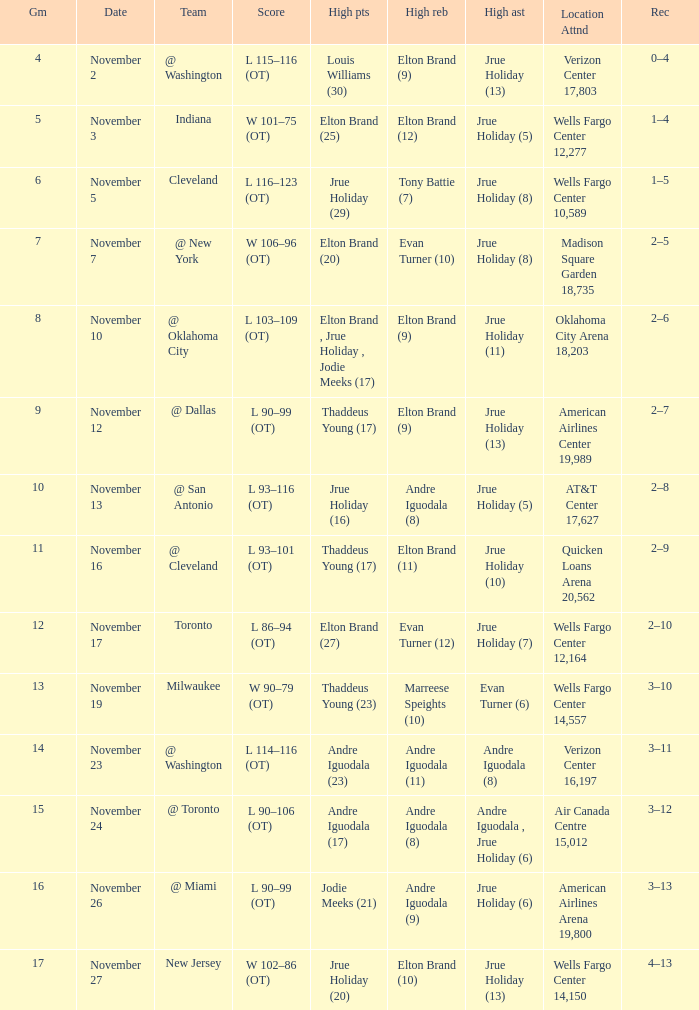What is the game number for the game with a score of l 90–106 (ot)? 15.0. Parse the table in full. {'header': ['Gm', 'Date', 'Team', 'Score', 'High pts', 'High reb', 'High ast', 'Location Attnd', 'Rec'], 'rows': [['4', 'November 2', '@ Washington', 'L 115–116 (OT)', 'Louis Williams (30)', 'Elton Brand (9)', 'Jrue Holiday (13)', 'Verizon Center 17,803', '0–4'], ['5', 'November 3', 'Indiana', 'W 101–75 (OT)', 'Elton Brand (25)', 'Elton Brand (12)', 'Jrue Holiday (5)', 'Wells Fargo Center 12,277', '1–4'], ['6', 'November 5', 'Cleveland', 'L 116–123 (OT)', 'Jrue Holiday (29)', 'Tony Battie (7)', 'Jrue Holiday (8)', 'Wells Fargo Center 10,589', '1–5'], ['7', 'November 7', '@ New York', 'W 106–96 (OT)', 'Elton Brand (20)', 'Evan Turner (10)', 'Jrue Holiday (8)', 'Madison Square Garden 18,735', '2–5'], ['8', 'November 10', '@ Oklahoma City', 'L 103–109 (OT)', 'Elton Brand , Jrue Holiday , Jodie Meeks (17)', 'Elton Brand (9)', 'Jrue Holiday (11)', 'Oklahoma City Arena 18,203', '2–6'], ['9', 'November 12', '@ Dallas', 'L 90–99 (OT)', 'Thaddeus Young (17)', 'Elton Brand (9)', 'Jrue Holiday (13)', 'American Airlines Center 19,989', '2–7'], ['10', 'November 13', '@ San Antonio', 'L 93–116 (OT)', 'Jrue Holiday (16)', 'Andre Iguodala (8)', 'Jrue Holiday (5)', 'AT&T Center 17,627', '2–8'], ['11', 'November 16', '@ Cleveland', 'L 93–101 (OT)', 'Thaddeus Young (17)', 'Elton Brand (11)', 'Jrue Holiday (10)', 'Quicken Loans Arena 20,562', '2–9'], ['12', 'November 17', 'Toronto', 'L 86–94 (OT)', 'Elton Brand (27)', 'Evan Turner (12)', 'Jrue Holiday (7)', 'Wells Fargo Center 12,164', '2–10'], ['13', 'November 19', 'Milwaukee', 'W 90–79 (OT)', 'Thaddeus Young (23)', 'Marreese Speights (10)', 'Evan Turner (6)', 'Wells Fargo Center 14,557', '3–10'], ['14', 'November 23', '@ Washington', 'L 114–116 (OT)', 'Andre Iguodala (23)', 'Andre Iguodala (11)', 'Andre Iguodala (8)', 'Verizon Center 16,197', '3–11'], ['15', 'November 24', '@ Toronto', 'L 90–106 (OT)', 'Andre Iguodala (17)', 'Andre Iguodala (8)', 'Andre Iguodala , Jrue Holiday (6)', 'Air Canada Centre 15,012', '3–12'], ['16', 'November 26', '@ Miami', 'L 90–99 (OT)', 'Jodie Meeks (21)', 'Andre Iguodala (9)', 'Jrue Holiday (6)', 'American Airlines Arena 19,800', '3–13'], ['17', 'November 27', 'New Jersey', 'W 102–86 (OT)', 'Jrue Holiday (20)', 'Elton Brand (10)', 'Jrue Holiday (13)', 'Wells Fargo Center 14,150', '4–13']]} 